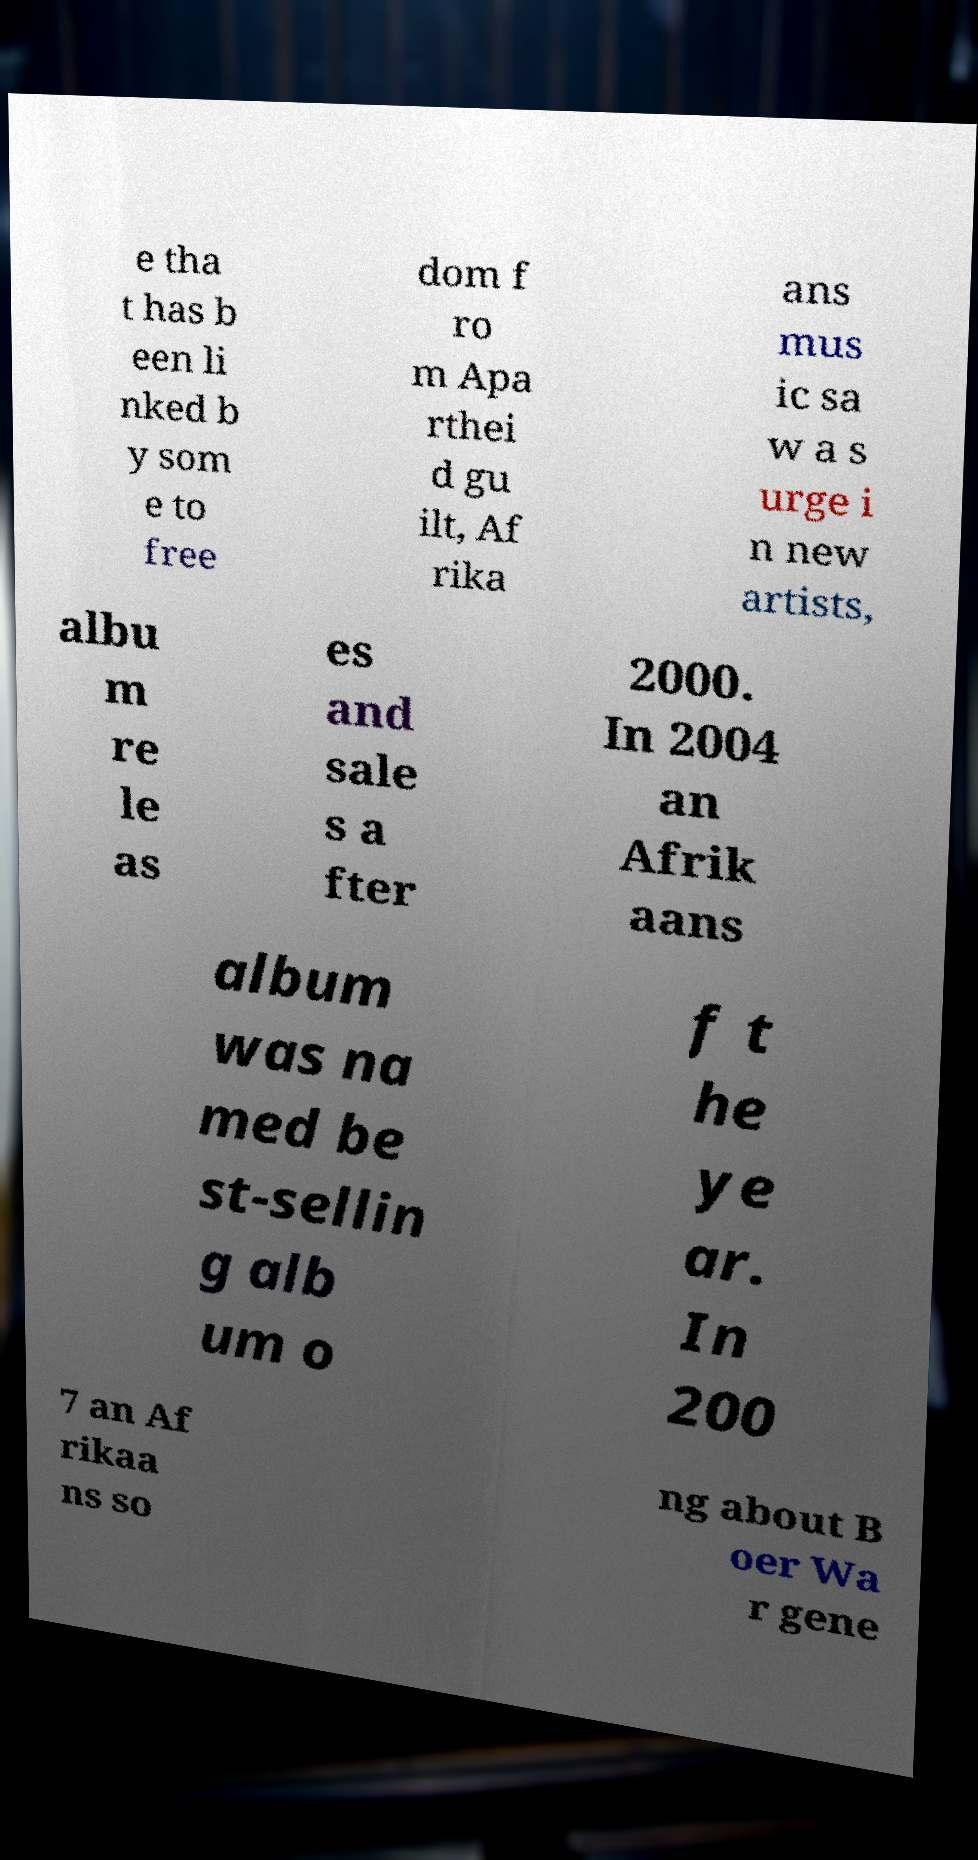Could you assist in decoding the text presented in this image and type it out clearly? e tha t has b een li nked b y som e to free dom f ro m Apa rthei d gu ilt, Af rika ans mus ic sa w a s urge i n new artists, albu m re le as es and sale s a fter 2000. In 2004 an Afrik aans album was na med be st-sellin g alb um o f t he ye ar. In 200 7 an Af rikaa ns so ng about B oer Wa r gene 